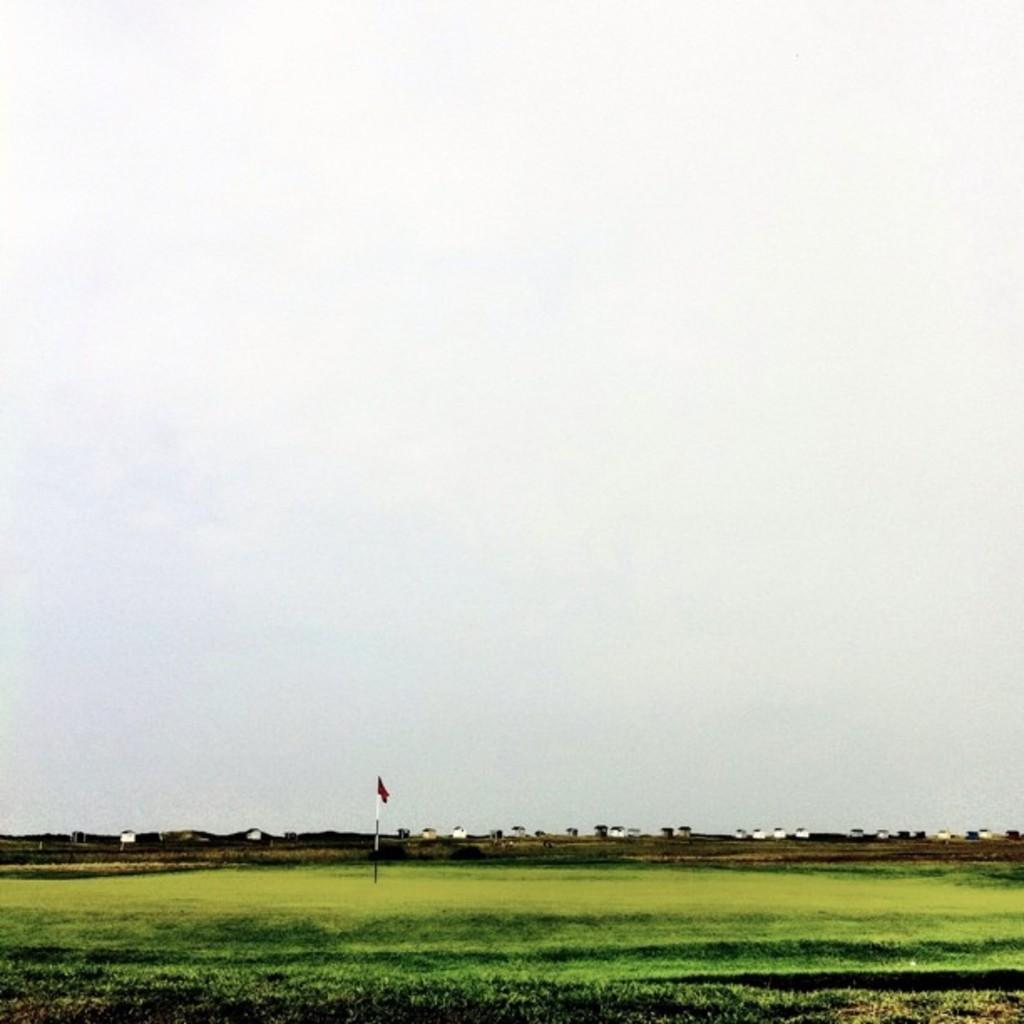What is on the ground in the image? There is a flag post with a flag on the ground. What type of structures can be seen in the image? There are buildings in the image. What part of the natural environment is visible in the image? The sky is visible in the image. What type of cushion is being used for the test in the image? There is no cushion or test present in the image. What type of power source is visible in the image? There is no power source visible in the image. 